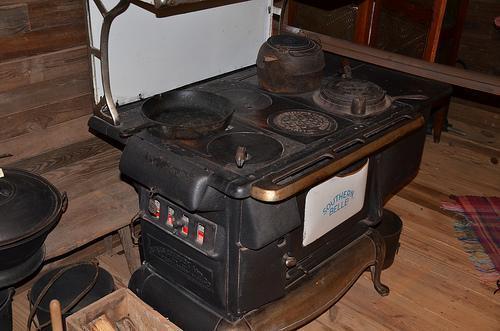How many cast-iron pans are on the stove?
Give a very brief answer. 1. 